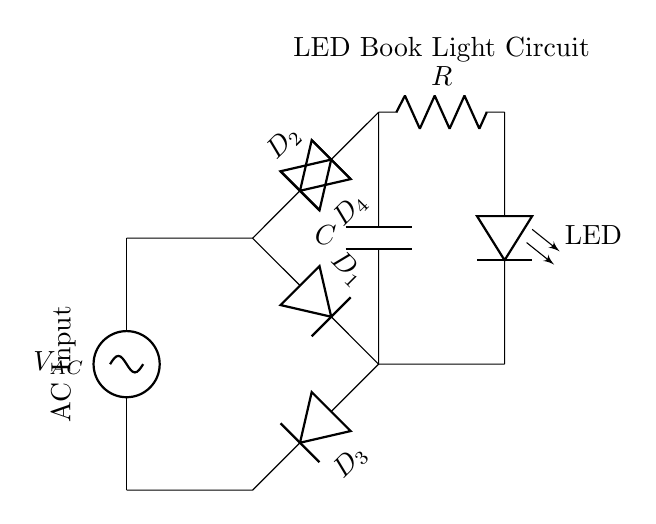What is the AC input voltage? The circuit diagram shows an AC voltage source labeled as V_AC, but no specific value is provided, indicating it depends on the application.
Answer: V_AC How many diodes are used in this rectifier? The circuit shows four diodes labeled D_1, D_2, D_3, and D_4, which are part of the bridge rectifier configuration.
Answer: Four What is the purpose of the capacitor in the circuit? The capacitor is labeled C and is used for smoothing the output voltage after rectification by reducing ripple, which improves the performance of the LED.
Answer: Smoothing What type of load is connected to the output? The load connected at the output of this circuit is an LED, indicated by the label LED in the diagram, meaning it lights up when powered.
Answer: LED Which component limits the current flowing to the LED? The circuit incorporates a resistor labeled R, which limits the current flowing through the LED to prevent damage and ensure proper operation.
Answer: Resistor How is the output voltage characterized in this rectifier? The output voltage is the result of the rectification of the AC input, where the voltage is adjusted by the diodes and further smoothed by the capacitor, typically giving a DC level.
Answer: DC voltage Why is a full-wave bridge rectifier used in this circuit? A full-wave bridge rectifier allows both halves of the AC waveform to be used, resulting in higher efficiency and a smoother DC output voltage for the LED compared to half-wave rectification.
Answer: Higher efficiency 